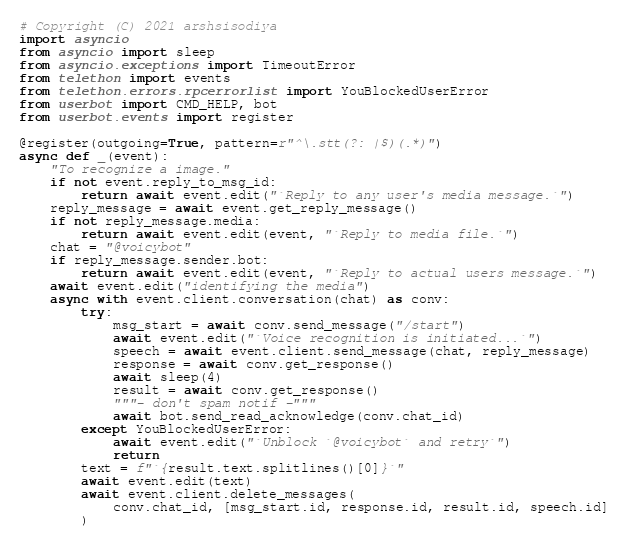<code> <loc_0><loc_0><loc_500><loc_500><_Python_># Copyright (C) 2021 arshsisodiya
import asyncio
from asyncio import sleep
from asyncio.exceptions import TimeoutError
from telethon import events
from telethon.errors.rpcerrorlist import YouBlockedUserError
from userbot import CMD_HELP, bot
from userbot.events import register

@register(outgoing=True, pattern=r"^\.stt(?: |$)(.*)")
async def _(event):
    "To recognize a image."
    if not event.reply_to_msg_id:
        return await event.edit("`Reply to any user's media message.`")
    reply_message = await event.get_reply_message()
    if not reply_message.media:
        return await event.edit(event, "`Reply to media file.`")
    chat = "@voicybot"
    if reply_message.sender.bot:
        return await event.edit(event, "`Reply to actual users message.`")
    await event.edit("identifying the media")
    async with event.client.conversation(chat) as conv:
        try:
            msg_start = await conv.send_message("/start")
            await event.edit("`Voice recognition is initiated...`")
            speech = await event.client.send_message(chat, reply_message)
            response = await conv.get_response()
            await sleep(4)
            result = await conv.get_response()
            """- don't spam notif -"""
            await bot.send_read_acknowledge(conv.chat_id)
        except YouBlockedUserError:
            await event.edit("`Unblock `@voicybot` and retry`")
            return
        text = f"`{result.text.splitlines()[0]}`"
        await event.edit(text)
        await event.client.delete_messages(
            conv.chat_id, [msg_start.id, response.id, result.id, speech.id]
        )

</code> 